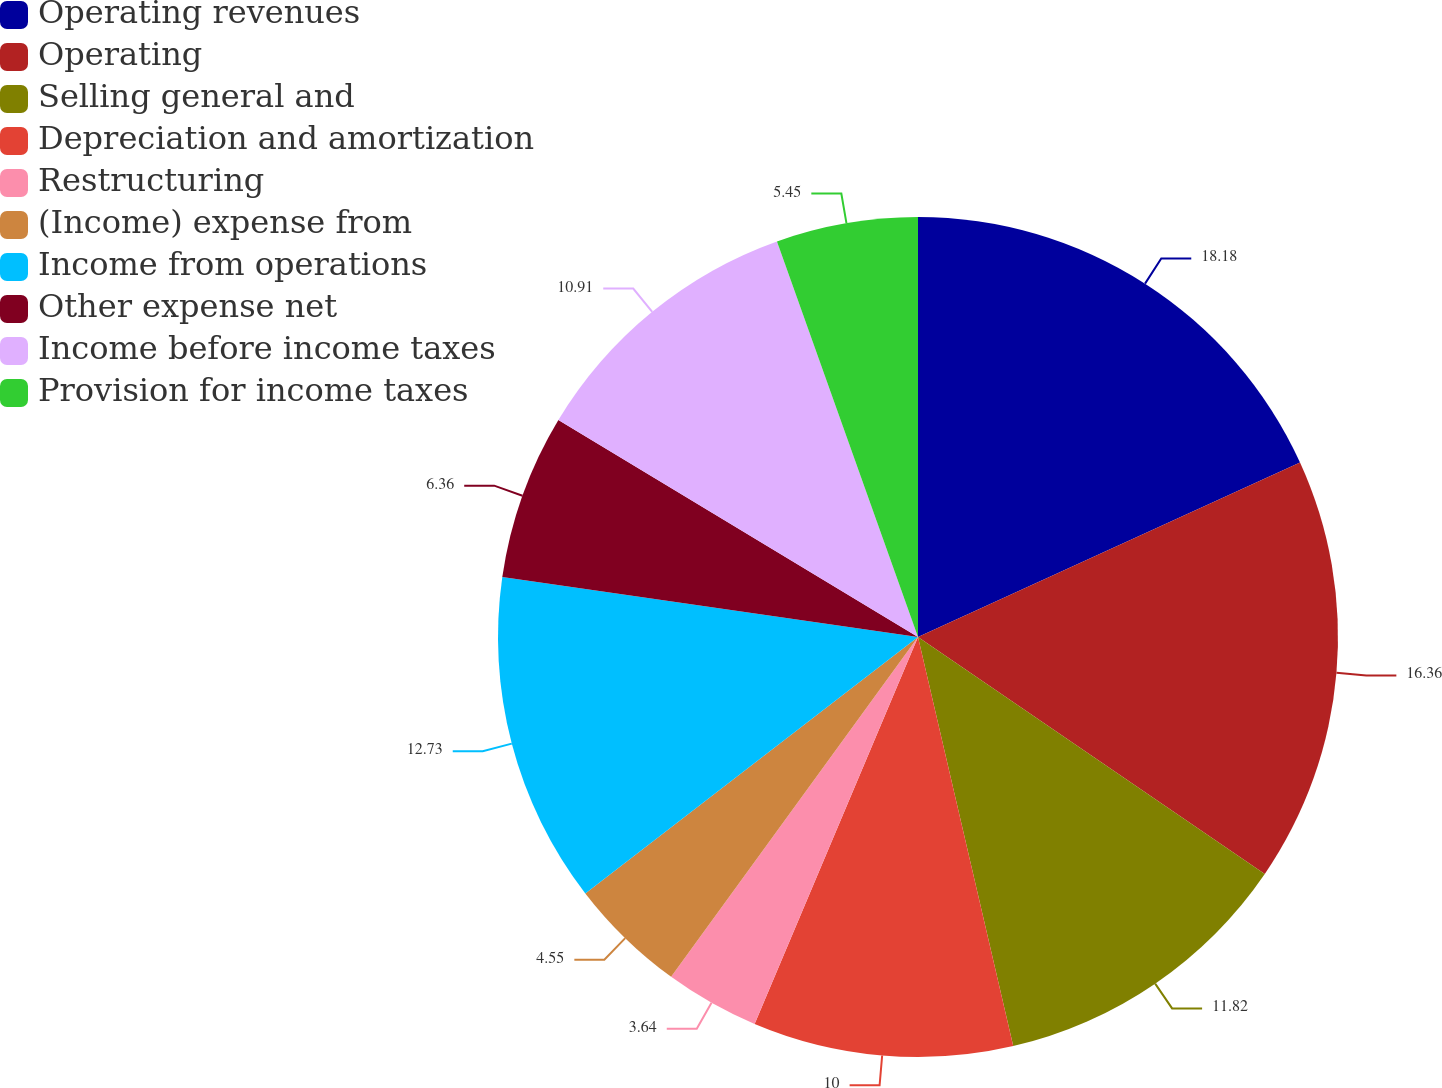Convert chart. <chart><loc_0><loc_0><loc_500><loc_500><pie_chart><fcel>Operating revenues<fcel>Operating<fcel>Selling general and<fcel>Depreciation and amortization<fcel>Restructuring<fcel>(Income) expense from<fcel>Income from operations<fcel>Other expense net<fcel>Income before income taxes<fcel>Provision for income taxes<nl><fcel>18.18%<fcel>16.36%<fcel>11.82%<fcel>10.0%<fcel>3.64%<fcel>4.55%<fcel>12.73%<fcel>6.36%<fcel>10.91%<fcel>5.45%<nl></chart> 